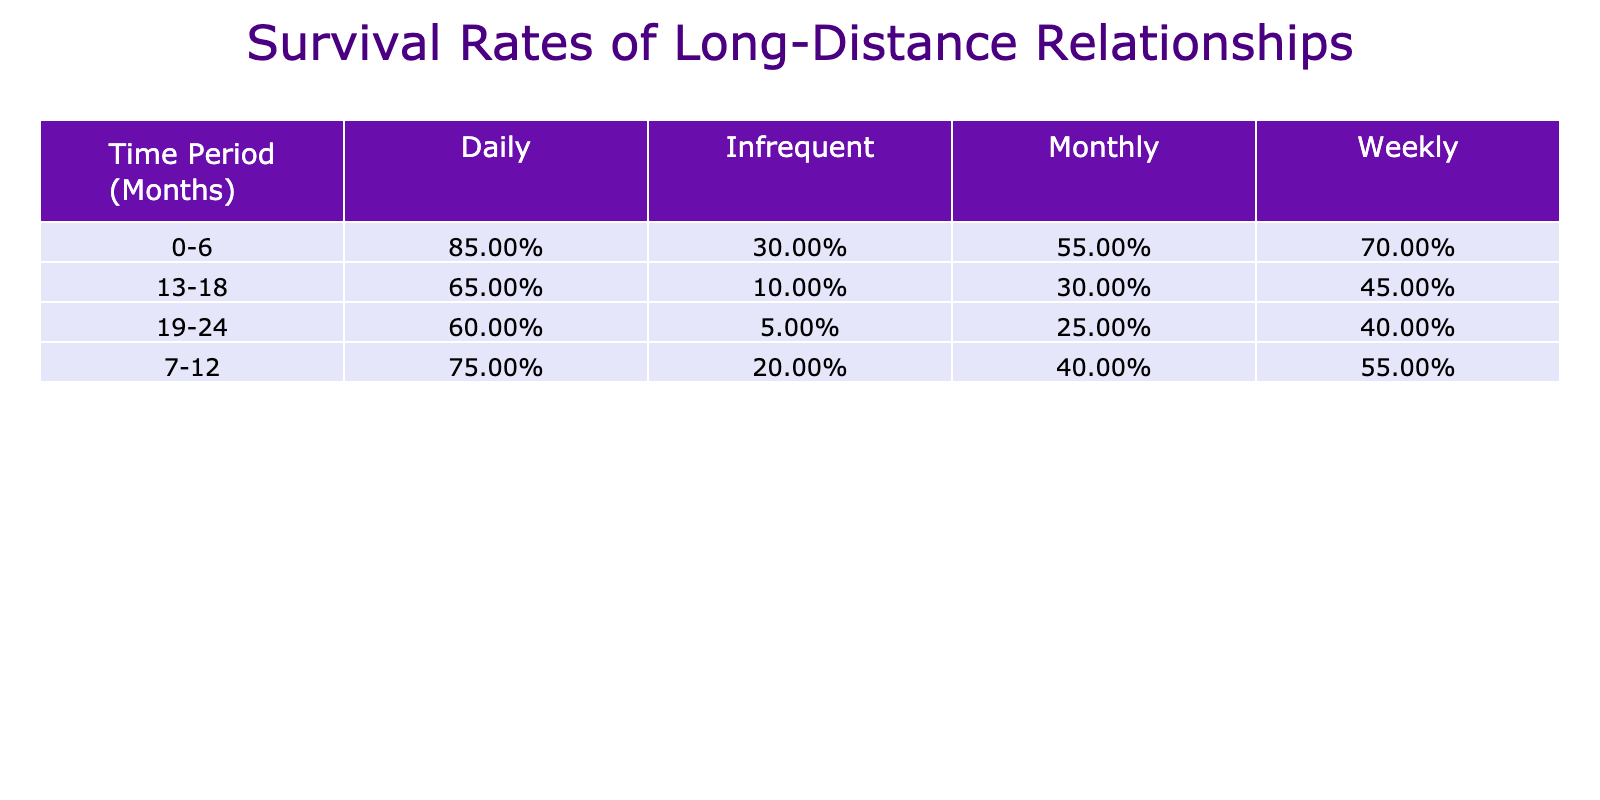What is the survival rate for relationships with daily communication after 13-18 months? According to the table, the survival rate for daily communication in the 13-18 month period is explicitly listed as 0.65.
Answer: 0.65 What communication frequency has the lowest survival rate at 19-24 months? By reviewing the 19-24 month survival rates across all communication frequencies, "Infrequent" has the lowest survival rate, which is 0.05.
Answer: Infrequent What is the average survival rate for weekly communication over the entire time period? The survival rates for weekly communication are: 0.70 (0-6 months), 0.55 (7-12 months), 0.45 (13-18 months), and 0.40 (19-24 months). The average is calculated as (0.70 + 0.55 + 0.45 + 0.40) / 4 = 0.52.
Answer: 0.52 Is the survival rate for relationships with monthly communication higher at 0-6 months compared to those with infrequent communication? For monthly communication at 0-6 months, the survival rate is 0.55, and for infrequent communication at the same period, it is 0.30. Since 0.55 is greater than 0.30, the answer is yes.
Answer: Yes What is the difference in survival rate between daily and weekly communication at 19-24 months? The survival rate for daily communication at 19-24 months is 0.60, and for weekly communication, it is 0.40. The difference is calculated as 0.60 - 0.40 = 0.20.
Answer: 0.20 After 6 months, does the survival rate decrease for all communication frequencies? Looking at the survival rates beyond the 0-6 months period: for daily, weekly, monthly, and infrequent communication, the rates are 0.75, 0.55, 0.40, and 0.20 respectively. These rates show a decrease compared to their initial rates, confirming that the survival rate decreases for all frequencies.
Answer: Yes What is the median survival rate for the 0-6 month period across all communication frequencies? The survival rates for the 0-6 month period are: 0.85 (daily), 0.70 (weekly), 0.55 (monthly), and 0.30 (infrequent). When arranged in order: 0.30, 0.55, 0.70, 0.85, the median (the average of the two middle values) is (0.55 + 0.70) / 2 = 0.625.
Answer: 0.625 Which communication frequency shows the most rapid decline in survival rate from 0-6 months to 19-24 months? For daily: (0.85 to 0.60), a decrease of 0.25; weekly: (0.70 to 0.40), a decrease of 0.30; monthly: (0.55 to 0.25), a decrease of 0.30; infrequent: (0.30 to 0.05), a decrease of 0.25. The infrequent communication has the most rapid decline with a decrease of 0.25 over the whole period.
Answer: Infrequent 